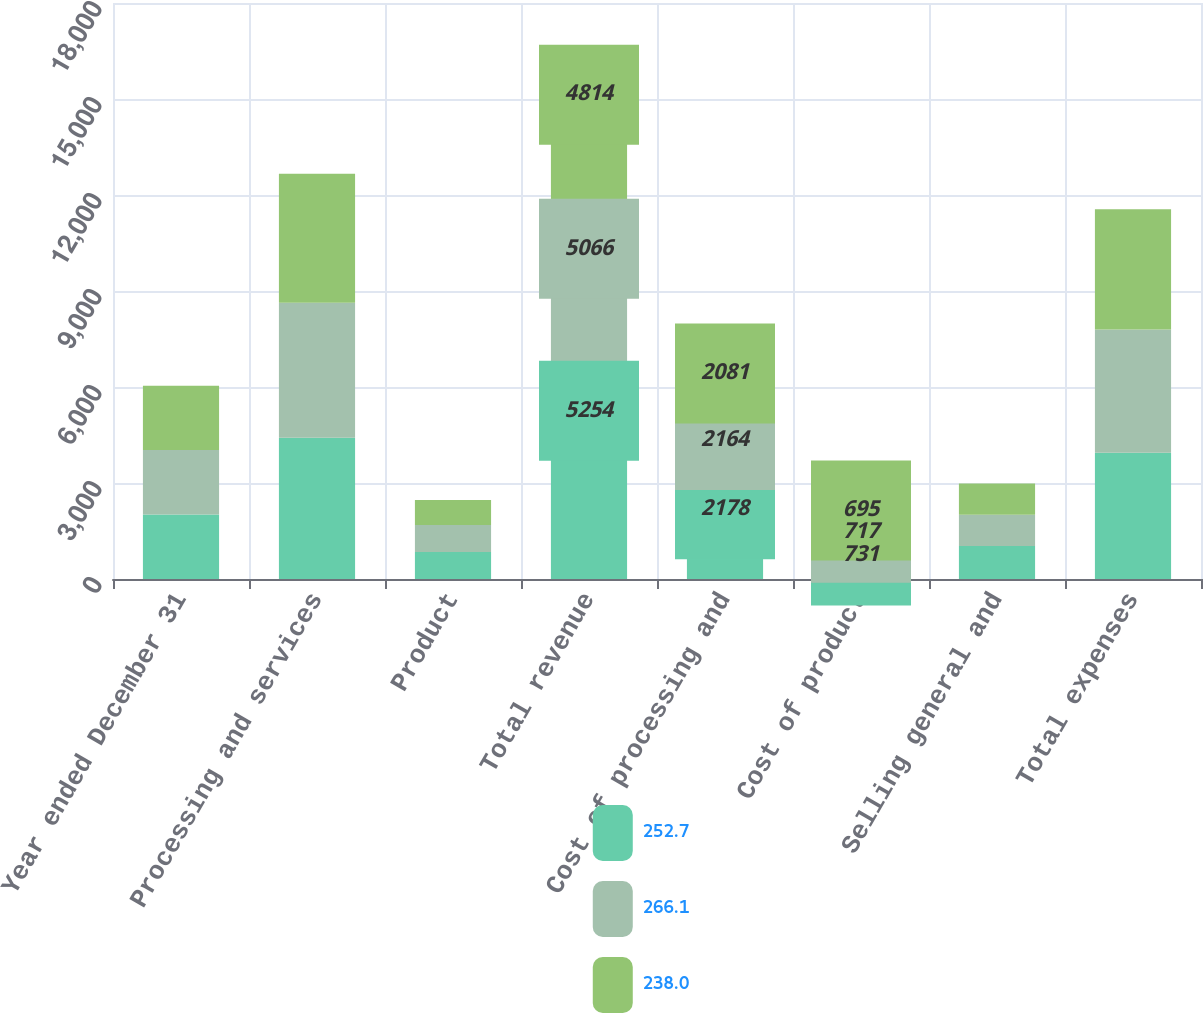<chart> <loc_0><loc_0><loc_500><loc_500><stacked_bar_chart><ecel><fcel>Year ended December 31<fcel>Processing and services<fcel>Product<fcel>Total revenue<fcel>Cost of processing and<fcel>Cost of product<fcel>Selling general and<fcel>Total expenses<nl><fcel>252.7<fcel>2015<fcel>4411<fcel>843<fcel>5254<fcel>2178<fcel>731<fcel>1034<fcel>3943<nl><fcel>266.1<fcel>2014<fcel>4219<fcel>847<fcel>5066<fcel>2164<fcel>717<fcel>975<fcel>3856<nl><fcel>238<fcel>2013<fcel>4035<fcel>779<fcel>4814<fcel>2081<fcel>695<fcel>977<fcel>3753<nl></chart> 